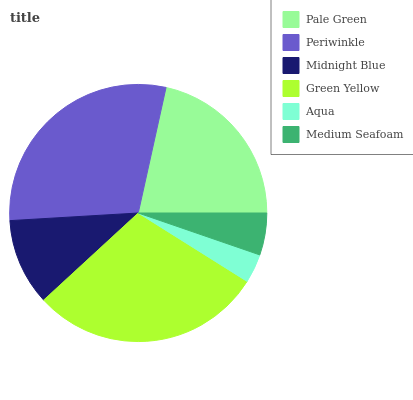Is Aqua the minimum?
Answer yes or no. Yes. Is Periwinkle the maximum?
Answer yes or no. Yes. Is Midnight Blue the minimum?
Answer yes or no. No. Is Midnight Blue the maximum?
Answer yes or no. No. Is Periwinkle greater than Midnight Blue?
Answer yes or no. Yes. Is Midnight Blue less than Periwinkle?
Answer yes or no. Yes. Is Midnight Blue greater than Periwinkle?
Answer yes or no. No. Is Periwinkle less than Midnight Blue?
Answer yes or no. No. Is Pale Green the high median?
Answer yes or no. Yes. Is Midnight Blue the low median?
Answer yes or no. Yes. Is Periwinkle the high median?
Answer yes or no. No. Is Green Yellow the low median?
Answer yes or no. No. 